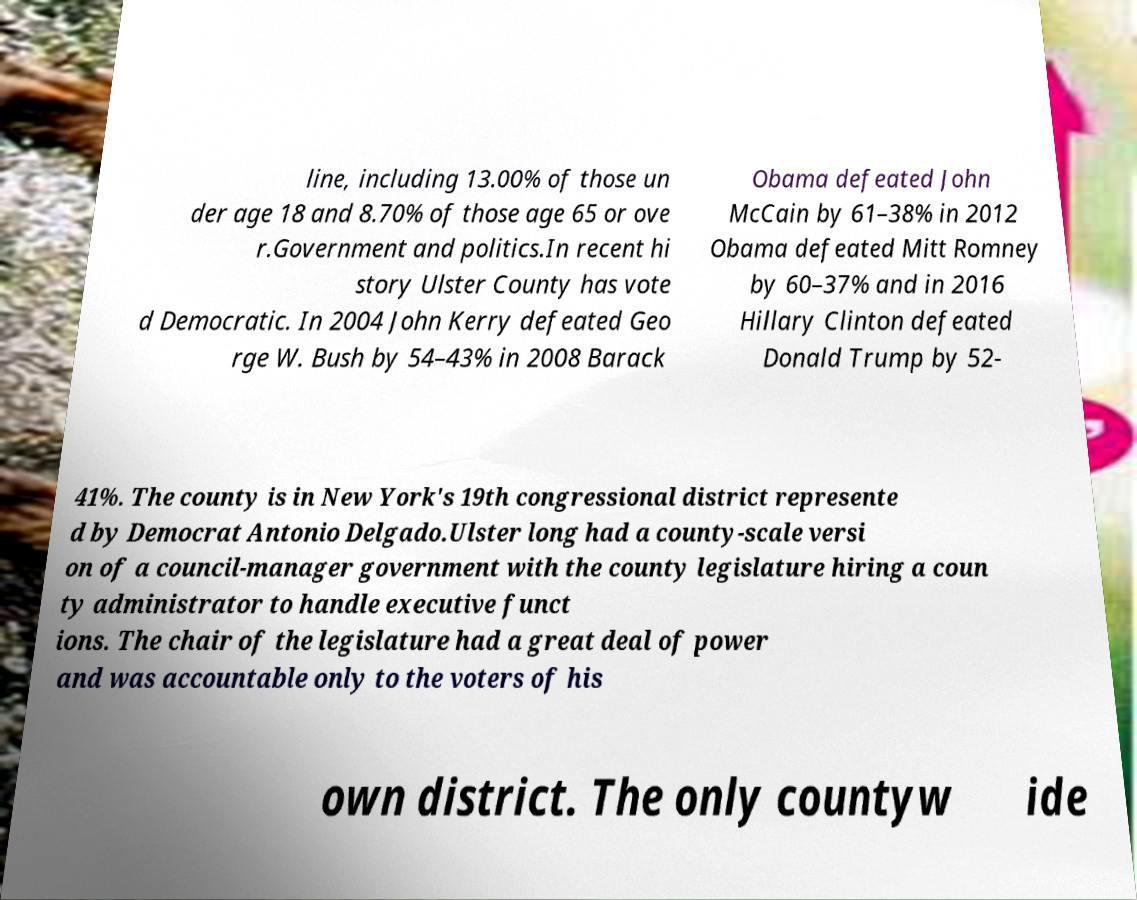What messages or text are displayed in this image? I need them in a readable, typed format. line, including 13.00% of those un der age 18 and 8.70% of those age 65 or ove r.Government and politics.In recent hi story Ulster County has vote d Democratic. In 2004 John Kerry defeated Geo rge W. Bush by 54–43% in 2008 Barack Obama defeated John McCain by 61–38% in 2012 Obama defeated Mitt Romney by 60–37% and in 2016 Hillary Clinton defeated Donald Trump by 52- 41%. The county is in New York's 19th congressional district represente d by Democrat Antonio Delgado.Ulster long had a county-scale versi on of a council-manager government with the county legislature hiring a coun ty administrator to handle executive funct ions. The chair of the legislature had a great deal of power and was accountable only to the voters of his own district. The only countyw ide 